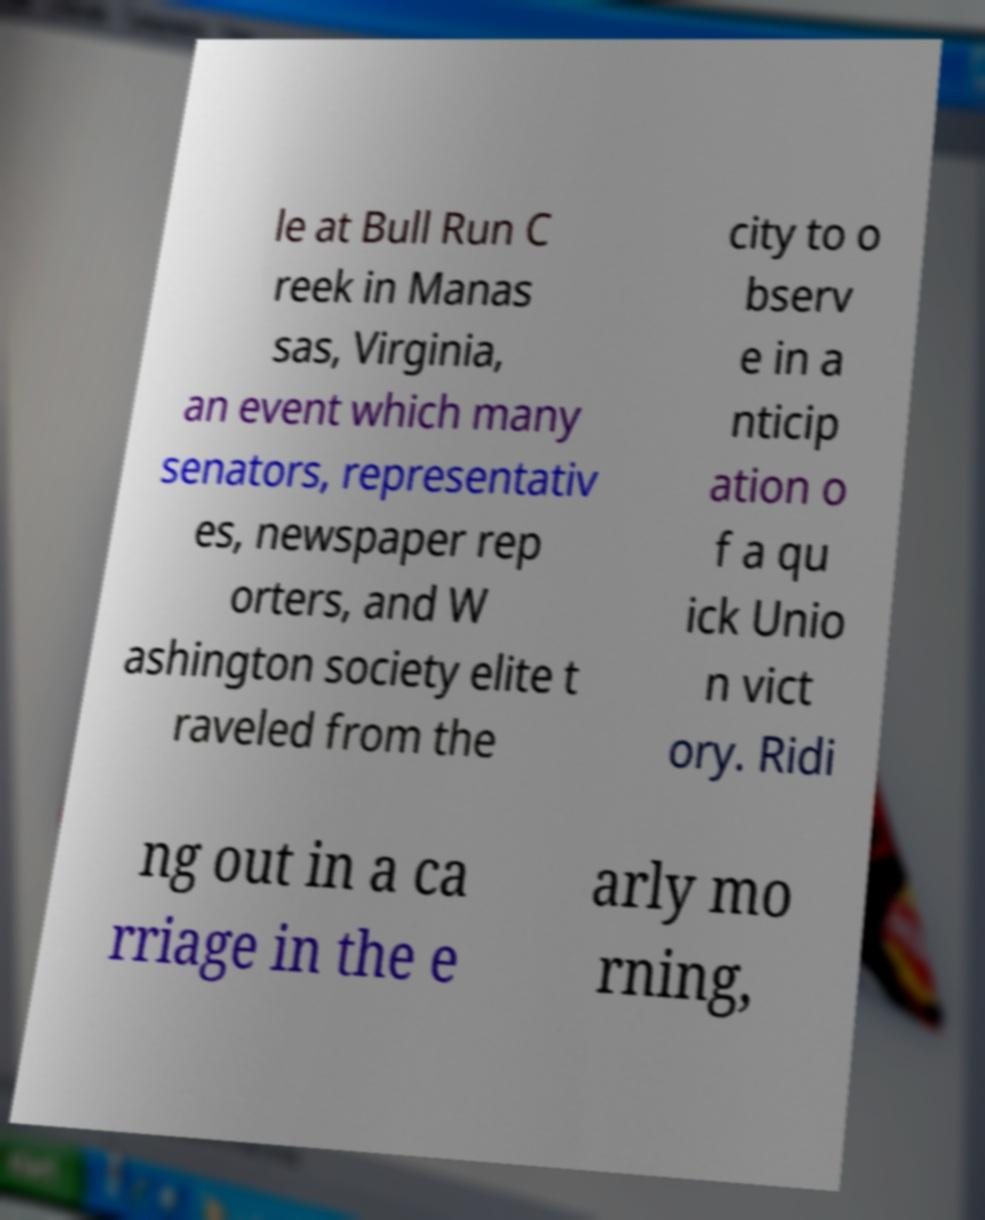Can you accurately transcribe the text from the provided image for me? le at Bull Run C reek in Manas sas, Virginia, an event which many senators, representativ es, newspaper rep orters, and W ashington society elite t raveled from the city to o bserv e in a nticip ation o f a qu ick Unio n vict ory. Ridi ng out in a ca rriage in the e arly mo rning, 